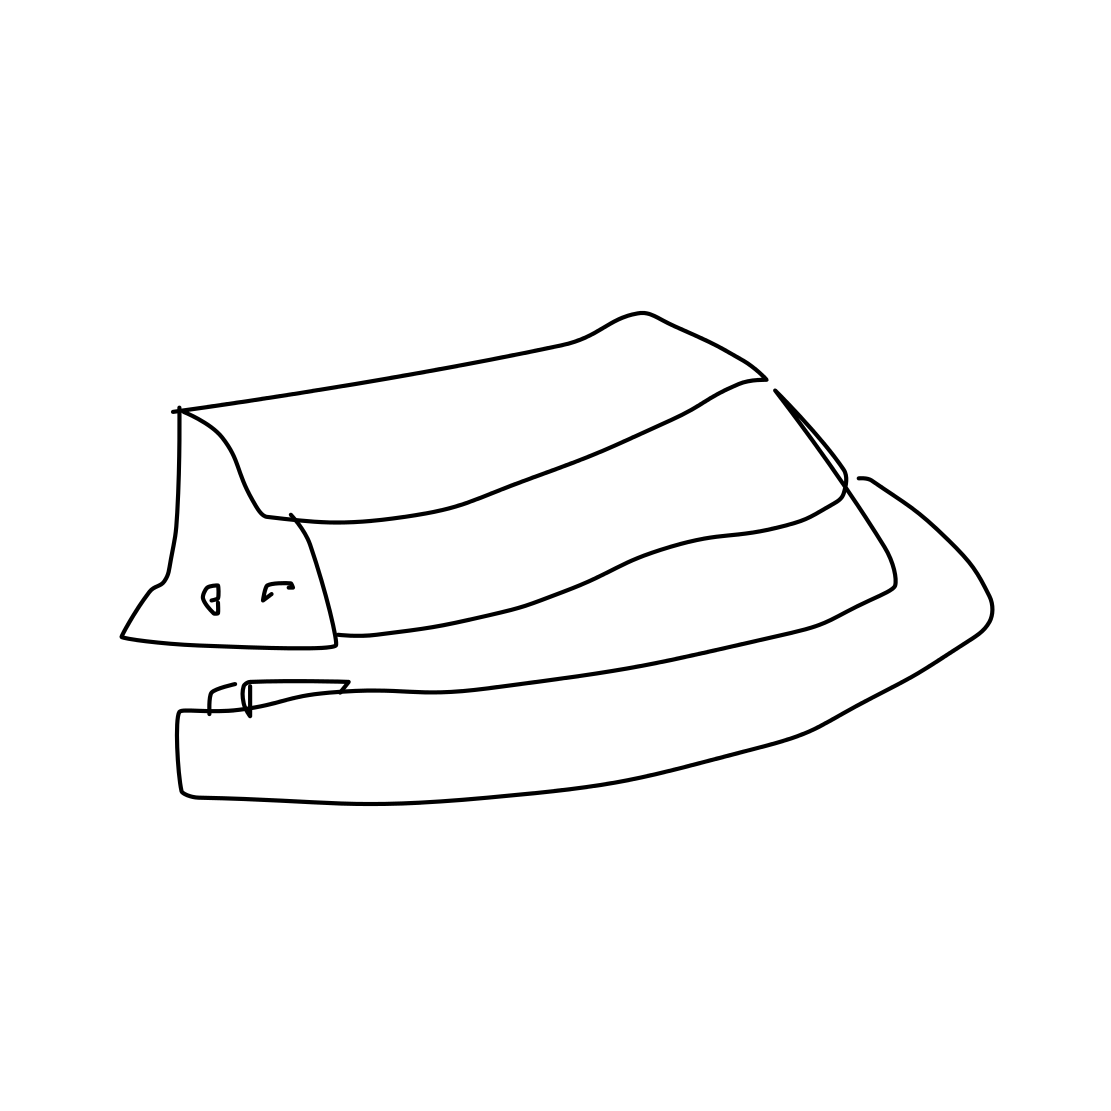Is this a book in the image? No 